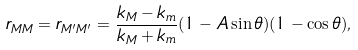<formula> <loc_0><loc_0><loc_500><loc_500>r _ { M M } = r _ { M ^ { \prime } M ^ { \prime } } = \frac { k _ { M } - k _ { m } } { k _ { M } + k _ { m } } ( 1 - A \sin \theta ) ( 1 - \cos \theta ) ,</formula> 